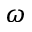<formula> <loc_0><loc_0><loc_500><loc_500>\omega</formula> 